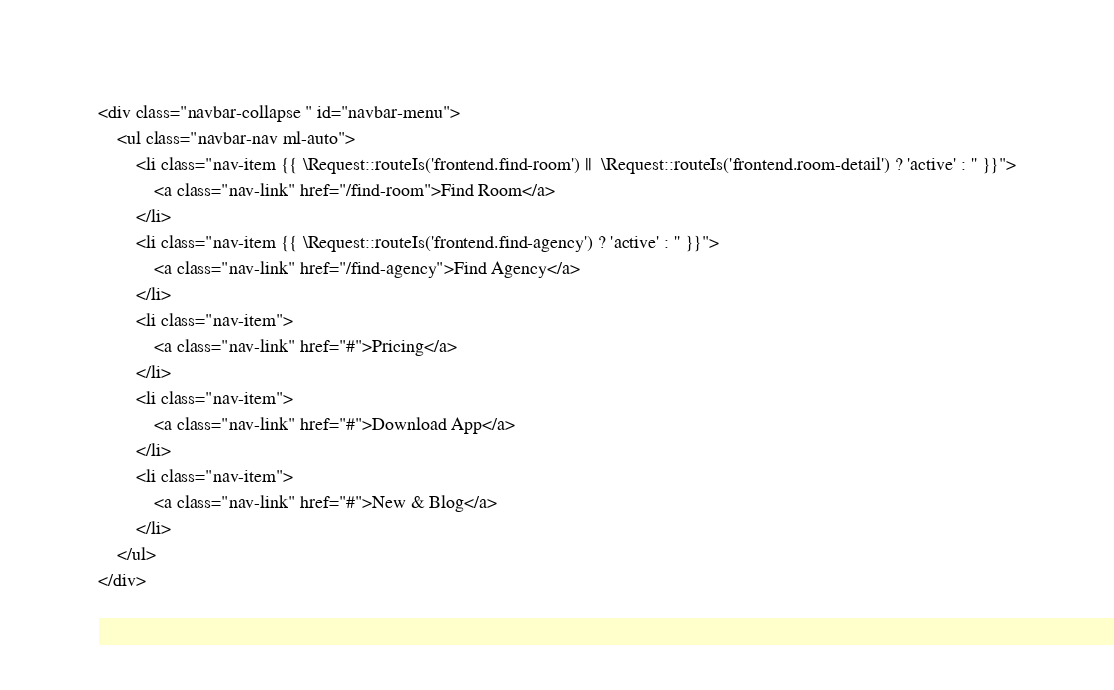<code> <loc_0><loc_0><loc_500><loc_500><_PHP_><div class="navbar-collapse " id="navbar-menu">
    <ul class="navbar-nav ml-auto">
        <li class="nav-item {{ \Request::routeIs('frontend.find-room') ||  \Request::routeIs('frontend.room-detail') ? 'active' : '' }}">
            <a class="nav-link" href="/find-room">Find Room</a>
        </li>
        <li class="nav-item {{ \Request::routeIs('frontend.find-agency') ? 'active' : '' }}">
            <a class="nav-link" href="/find-agency">Find Agency</a>
        </li>
        <li class="nav-item">
            <a class="nav-link" href="#">Pricing</a>
        </li>
        <li class="nav-item">
            <a class="nav-link" href="#">Download App</a>
        </li>
        <li class="nav-item">
            <a class="nav-link" href="#">New & Blog</a>
        </li>
    </ul>
</div></code> 